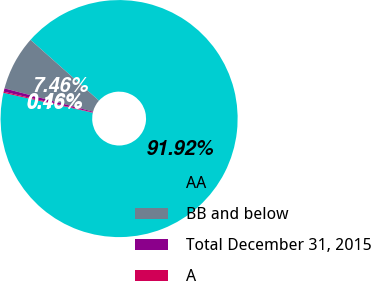<chart> <loc_0><loc_0><loc_500><loc_500><pie_chart><fcel>AA<fcel>BB and below<fcel>Total December 31, 2015<fcel>A<nl><fcel>91.92%<fcel>7.46%<fcel>0.46%<fcel>0.16%<nl></chart> 